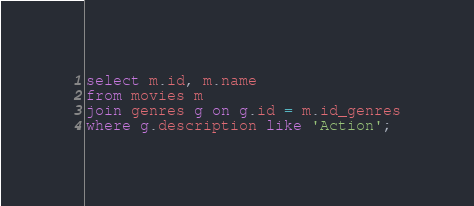<code> <loc_0><loc_0><loc_500><loc_500><_SQL_>select m.id, m.name 
from movies m
join genres g on g.id = m.id_genres
where g.description like 'Action';</code> 